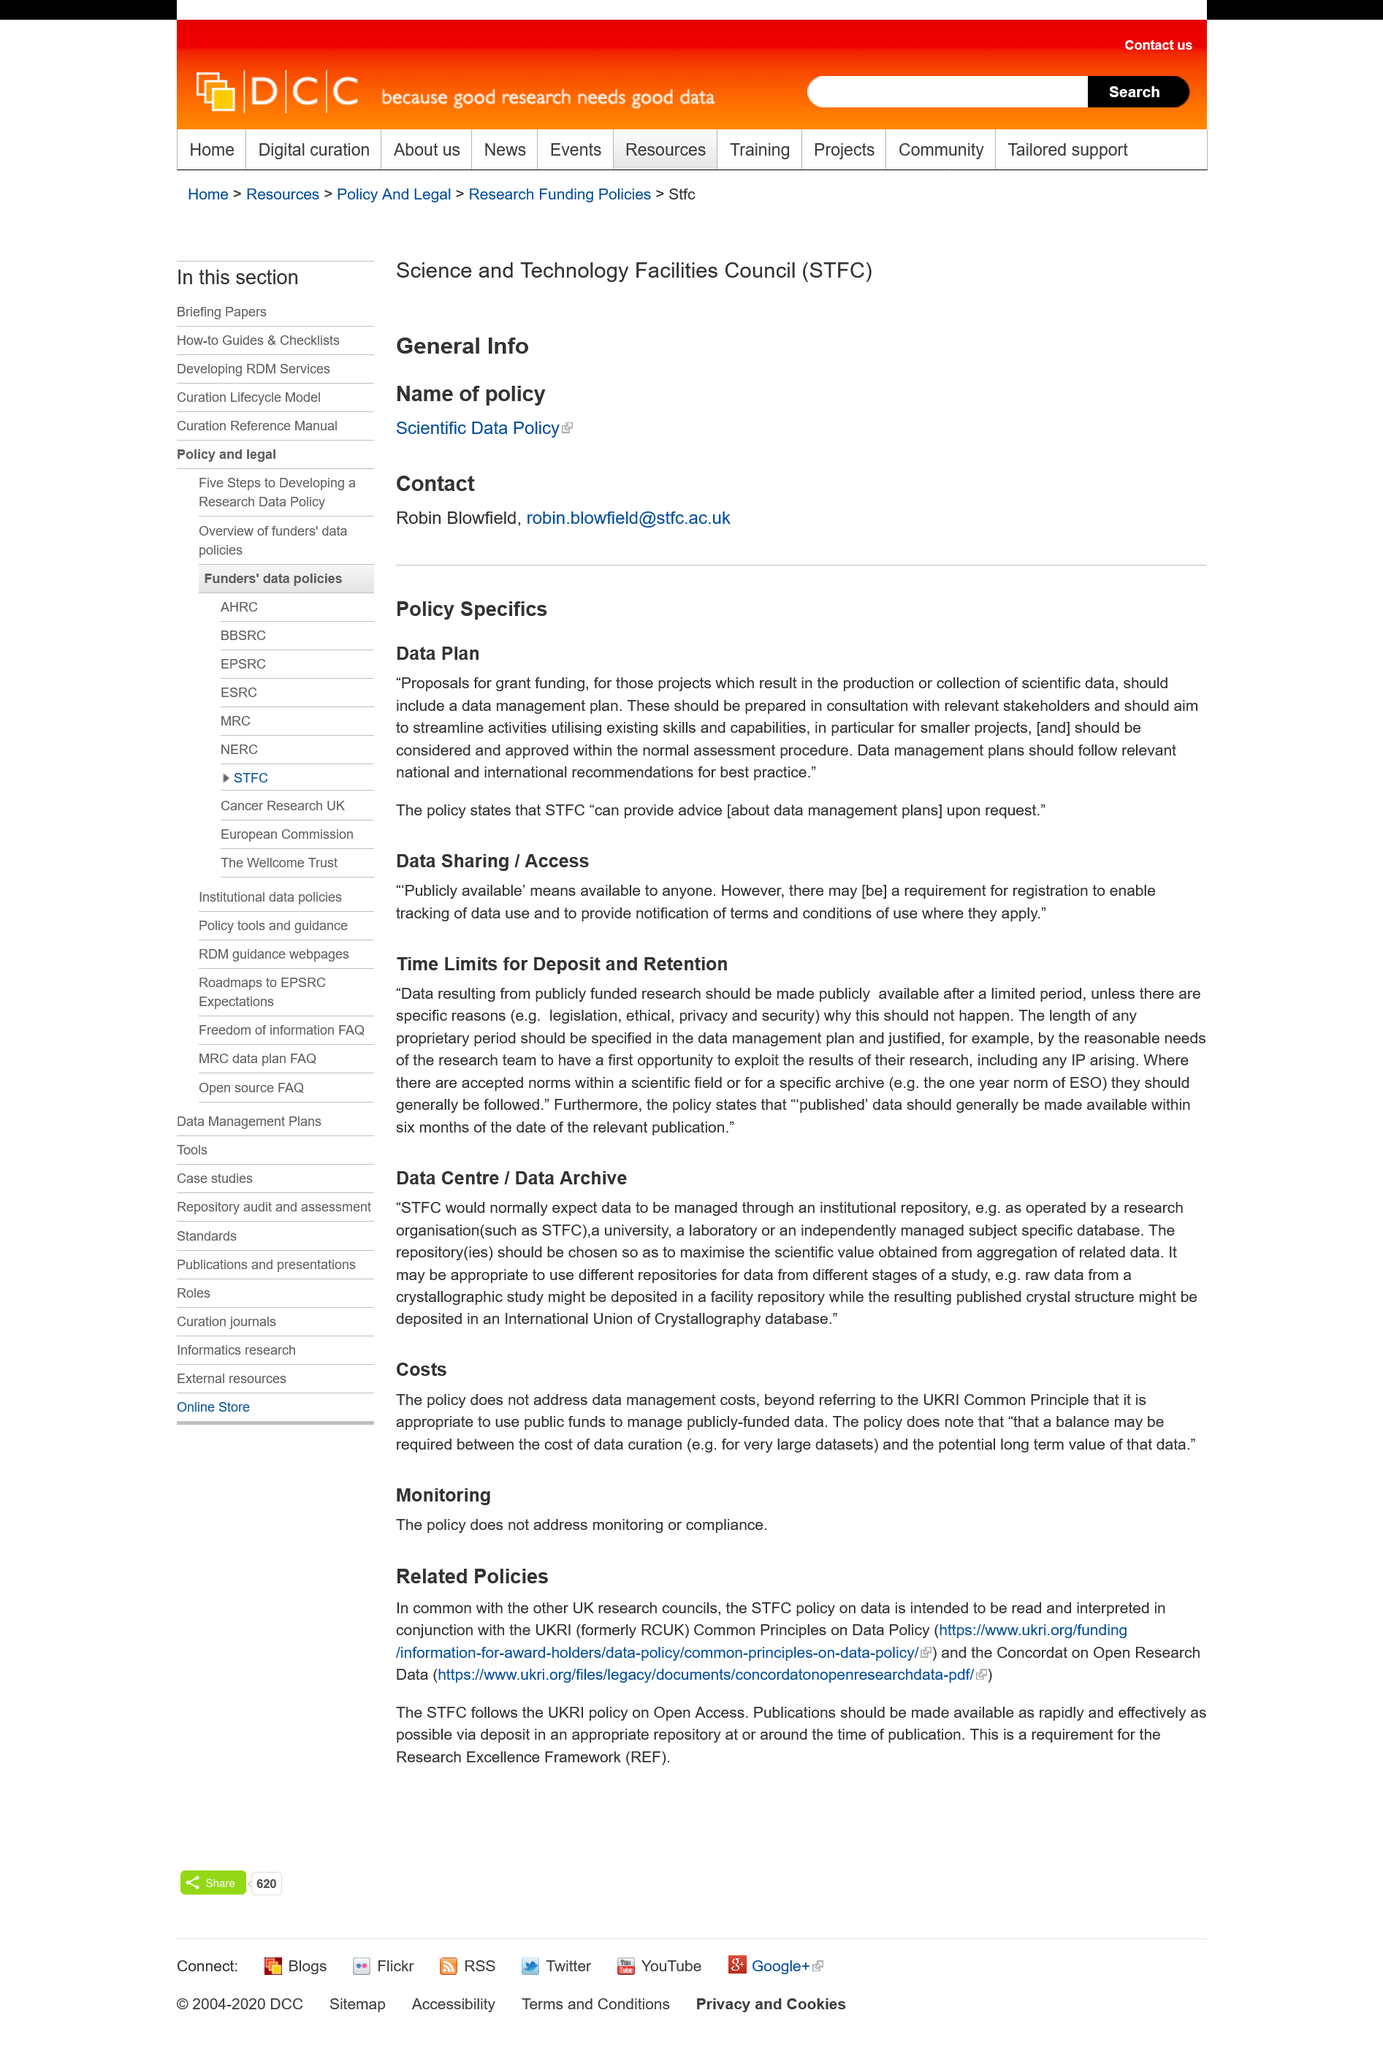Identify some key points in this picture. Publicly available means that it is accessible to the general public and can be obtained by anyone. According to related policies, REF stands for Research Excellence Framework. What is STFC? STFC is a research organization that focuses on scientific research and technological development. Data should be managed through an institutional repository in accordance with the expectations of the STFC. The research councils mentioned in the article are from the United Kingdom. 